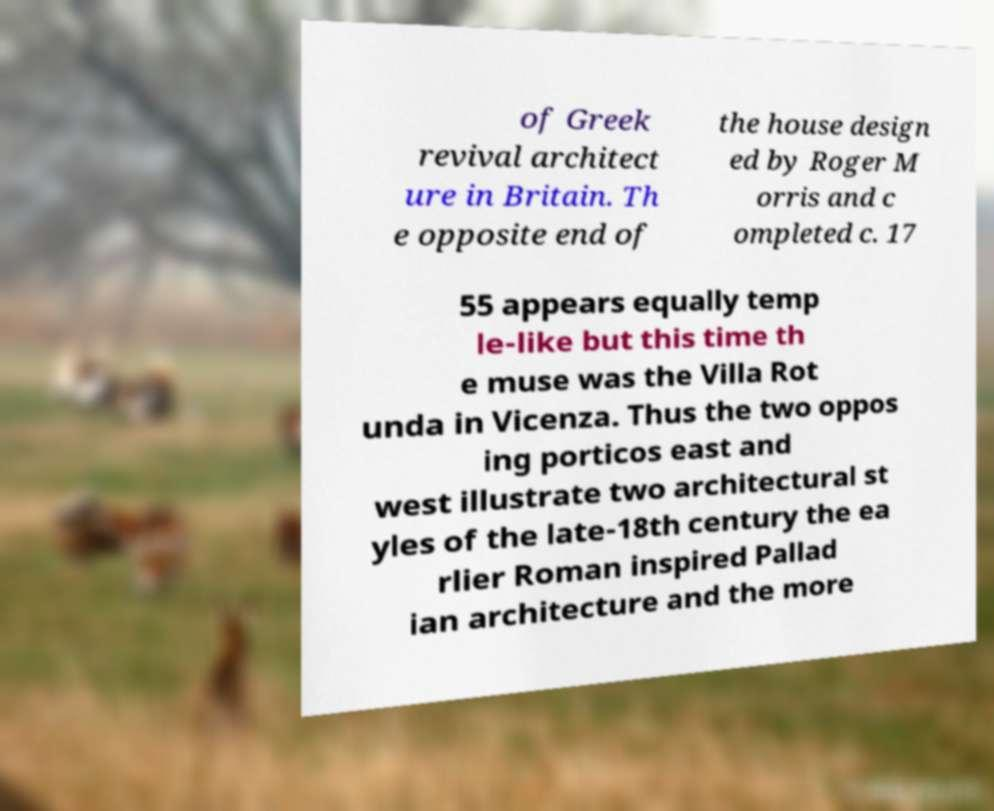I need the written content from this picture converted into text. Can you do that? of Greek revival architect ure in Britain. Th e opposite end of the house design ed by Roger M orris and c ompleted c. 17 55 appears equally temp le-like but this time th e muse was the Villa Rot unda in Vicenza. Thus the two oppos ing porticos east and west illustrate two architectural st yles of the late-18th century the ea rlier Roman inspired Pallad ian architecture and the more 